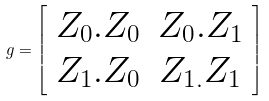<formula> <loc_0><loc_0><loc_500><loc_500>g = \left [ \begin{array} { c c } Z _ { 0 } . Z _ { 0 } & Z _ { 0 } . Z _ { 1 } \\ Z _ { 1 } . Z _ { 0 } & Z _ { 1 . } Z _ { 1 } \end{array} \right ]</formula> 